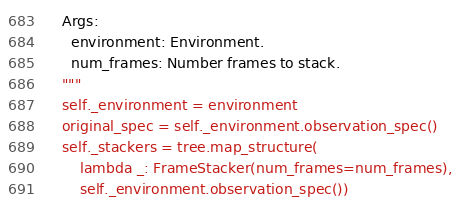<code> <loc_0><loc_0><loc_500><loc_500><_Python_>    Args:
      environment: Environment.
      num_frames: Number frames to stack.
    """
    self._environment = environment
    original_spec = self._environment.observation_spec()
    self._stackers = tree.map_structure(
        lambda _: FrameStacker(num_frames=num_frames),
        self._environment.observation_spec())</code> 